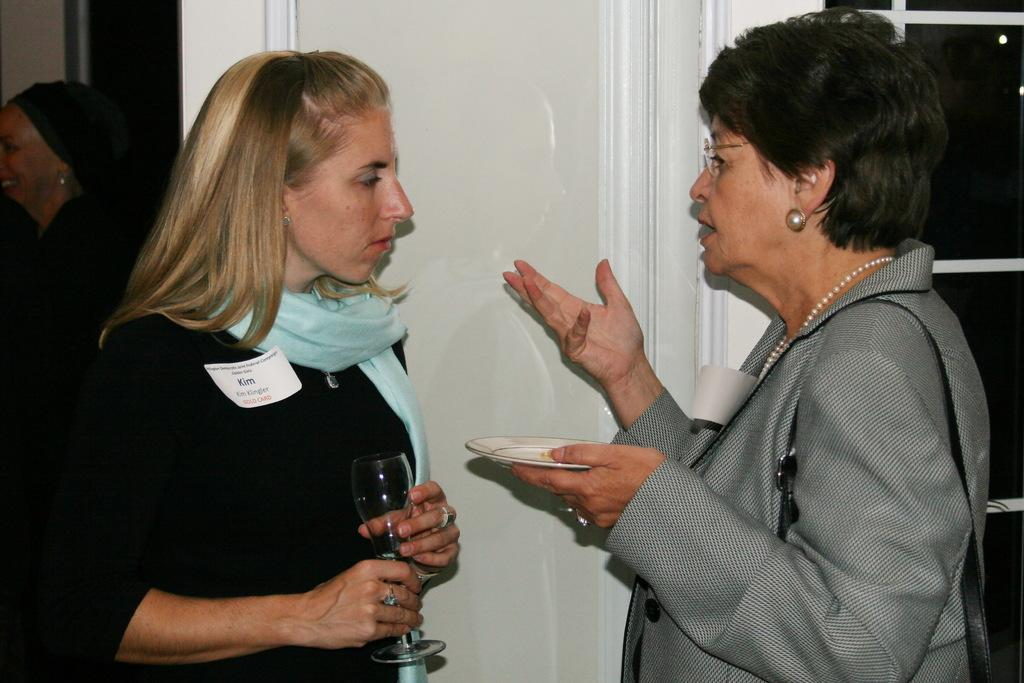What is the woman wearing a scarf and a black dress holding in the image? The woman is holding a glass. What is the other woman wearing, and what is she doing? The other woman is wearing a suit and talking. What is the woman in the suit holding? The woman in the suit is holding a plate. How is the woman wearing a scarf and a black dress positioned in the image? One woman is standing and smiling. What type of wind can be seen blowing in the image? There is no wind present in the image. Can you describe the coastline visible in the image? There is no coastline visible in the image. 